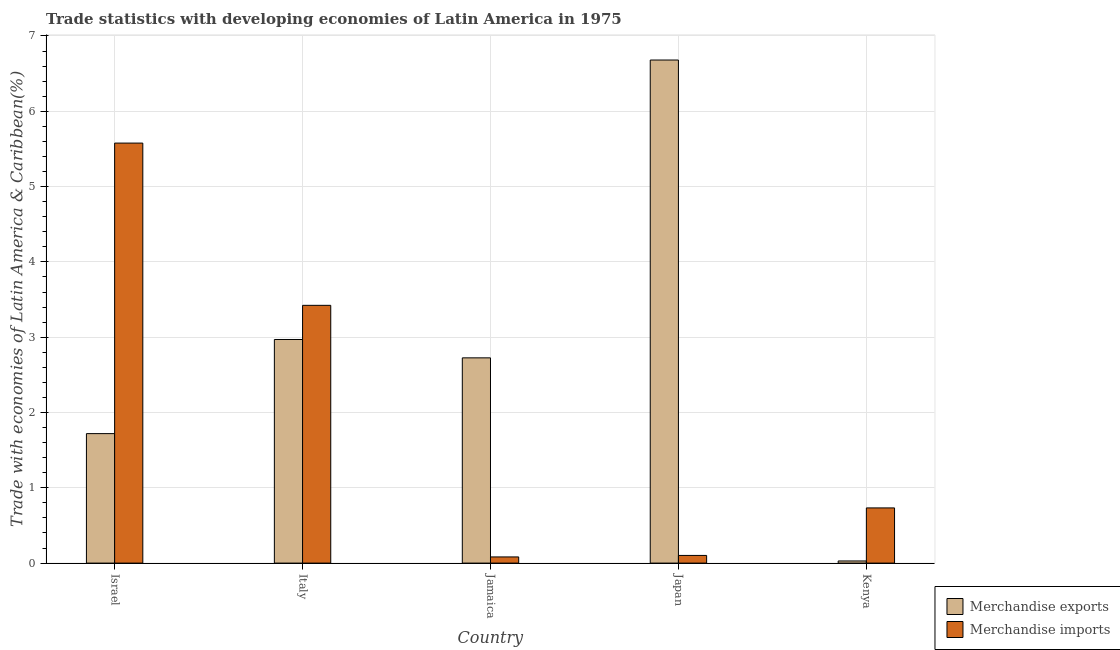Are the number of bars on each tick of the X-axis equal?
Keep it short and to the point. Yes. What is the label of the 1st group of bars from the left?
Your response must be concise. Israel. In how many cases, is the number of bars for a given country not equal to the number of legend labels?
Your answer should be very brief. 0. What is the merchandise exports in Italy?
Make the answer very short. 2.97. Across all countries, what is the maximum merchandise exports?
Make the answer very short. 6.68. Across all countries, what is the minimum merchandise exports?
Your answer should be compact. 0.03. In which country was the merchandise exports minimum?
Keep it short and to the point. Kenya. What is the total merchandise exports in the graph?
Offer a terse response. 14.12. What is the difference between the merchandise exports in Jamaica and that in Japan?
Your answer should be very brief. -3.96. What is the difference between the merchandise exports in Japan and the merchandise imports in Jamaica?
Offer a very short reply. 6.6. What is the average merchandise imports per country?
Make the answer very short. 1.98. What is the difference between the merchandise imports and merchandise exports in Israel?
Your response must be concise. 3.86. In how many countries, is the merchandise exports greater than 4 %?
Make the answer very short. 1. What is the ratio of the merchandise exports in Jamaica to that in Japan?
Your response must be concise. 0.41. Is the merchandise exports in Italy less than that in Jamaica?
Provide a short and direct response. No. What is the difference between the highest and the second highest merchandise imports?
Make the answer very short. 2.15. What is the difference between the highest and the lowest merchandise imports?
Make the answer very short. 5.5. In how many countries, is the merchandise exports greater than the average merchandise exports taken over all countries?
Ensure brevity in your answer.  2. Is the sum of the merchandise exports in Israel and Jamaica greater than the maximum merchandise imports across all countries?
Your response must be concise. No. What does the 1st bar from the left in Kenya represents?
Your answer should be very brief. Merchandise exports. What does the 2nd bar from the right in Israel represents?
Keep it short and to the point. Merchandise exports. How many bars are there?
Ensure brevity in your answer.  10. How many countries are there in the graph?
Give a very brief answer. 5. Are the values on the major ticks of Y-axis written in scientific E-notation?
Provide a succinct answer. No. How many legend labels are there?
Your answer should be compact. 2. How are the legend labels stacked?
Your answer should be very brief. Vertical. What is the title of the graph?
Offer a terse response. Trade statistics with developing economies of Latin America in 1975. Does "Goods and services" appear as one of the legend labels in the graph?
Your answer should be compact. No. What is the label or title of the X-axis?
Your answer should be compact. Country. What is the label or title of the Y-axis?
Give a very brief answer. Trade with economies of Latin America & Caribbean(%). What is the Trade with economies of Latin America & Caribbean(%) in Merchandise exports in Israel?
Your response must be concise. 1.72. What is the Trade with economies of Latin America & Caribbean(%) of Merchandise imports in Israel?
Provide a succinct answer. 5.58. What is the Trade with economies of Latin America & Caribbean(%) in Merchandise exports in Italy?
Give a very brief answer. 2.97. What is the Trade with economies of Latin America & Caribbean(%) in Merchandise imports in Italy?
Your answer should be compact. 3.42. What is the Trade with economies of Latin America & Caribbean(%) of Merchandise exports in Jamaica?
Make the answer very short. 2.73. What is the Trade with economies of Latin America & Caribbean(%) in Merchandise imports in Jamaica?
Ensure brevity in your answer.  0.08. What is the Trade with economies of Latin America & Caribbean(%) of Merchandise exports in Japan?
Offer a terse response. 6.68. What is the Trade with economies of Latin America & Caribbean(%) in Merchandise imports in Japan?
Keep it short and to the point. 0.1. What is the Trade with economies of Latin America & Caribbean(%) in Merchandise exports in Kenya?
Keep it short and to the point. 0.03. What is the Trade with economies of Latin America & Caribbean(%) in Merchandise imports in Kenya?
Offer a very short reply. 0.73. Across all countries, what is the maximum Trade with economies of Latin America & Caribbean(%) in Merchandise exports?
Offer a very short reply. 6.68. Across all countries, what is the maximum Trade with economies of Latin America & Caribbean(%) in Merchandise imports?
Give a very brief answer. 5.58. Across all countries, what is the minimum Trade with economies of Latin America & Caribbean(%) in Merchandise exports?
Provide a succinct answer. 0.03. Across all countries, what is the minimum Trade with economies of Latin America & Caribbean(%) of Merchandise imports?
Your answer should be very brief. 0.08. What is the total Trade with economies of Latin America & Caribbean(%) of Merchandise exports in the graph?
Provide a short and direct response. 14.12. What is the total Trade with economies of Latin America & Caribbean(%) of Merchandise imports in the graph?
Your answer should be compact. 9.92. What is the difference between the Trade with economies of Latin America & Caribbean(%) of Merchandise exports in Israel and that in Italy?
Your answer should be very brief. -1.25. What is the difference between the Trade with economies of Latin America & Caribbean(%) of Merchandise imports in Israel and that in Italy?
Make the answer very short. 2.15. What is the difference between the Trade with economies of Latin America & Caribbean(%) of Merchandise exports in Israel and that in Jamaica?
Offer a terse response. -1.01. What is the difference between the Trade with economies of Latin America & Caribbean(%) of Merchandise imports in Israel and that in Jamaica?
Keep it short and to the point. 5.5. What is the difference between the Trade with economies of Latin America & Caribbean(%) of Merchandise exports in Israel and that in Japan?
Keep it short and to the point. -4.96. What is the difference between the Trade with economies of Latin America & Caribbean(%) of Merchandise imports in Israel and that in Japan?
Your answer should be very brief. 5.48. What is the difference between the Trade with economies of Latin America & Caribbean(%) of Merchandise exports in Israel and that in Kenya?
Your answer should be very brief. 1.69. What is the difference between the Trade with economies of Latin America & Caribbean(%) of Merchandise imports in Israel and that in Kenya?
Give a very brief answer. 4.84. What is the difference between the Trade with economies of Latin America & Caribbean(%) of Merchandise exports in Italy and that in Jamaica?
Give a very brief answer. 0.24. What is the difference between the Trade with economies of Latin America & Caribbean(%) in Merchandise imports in Italy and that in Jamaica?
Your response must be concise. 3.34. What is the difference between the Trade with economies of Latin America & Caribbean(%) in Merchandise exports in Italy and that in Japan?
Make the answer very short. -3.71. What is the difference between the Trade with economies of Latin America & Caribbean(%) of Merchandise imports in Italy and that in Japan?
Provide a short and direct response. 3.32. What is the difference between the Trade with economies of Latin America & Caribbean(%) in Merchandise exports in Italy and that in Kenya?
Your answer should be very brief. 2.94. What is the difference between the Trade with economies of Latin America & Caribbean(%) in Merchandise imports in Italy and that in Kenya?
Your answer should be very brief. 2.69. What is the difference between the Trade with economies of Latin America & Caribbean(%) of Merchandise exports in Jamaica and that in Japan?
Your response must be concise. -3.96. What is the difference between the Trade with economies of Latin America & Caribbean(%) of Merchandise imports in Jamaica and that in Japan?
Provide a succinct answer. -0.02. What is the difference between the Trade with economies of Latin America & Caribbean(%) of Merchandise exports in Jamaica and that in Kenya?
Make the answer very short. 2.7. What is the difference between the Trade with economies of Latin America & Caribbean(%) of Merchandise imports in Jamaica and that in Kenya?
Your answer should be compact. -0.65. What is the difference between the Trade with economies of Latin America & Caribbean(%) in Merchandise exports in Japan and that in Kenya?
Keep it short and to the point. 6.65. What is the difference between the Trade with economies of Latin America & Caribbean(%) in Merchandise imports in Japan and that in Kenya?
Ensure brevity in your answer.  -0.63. What is the difference between the Trade with economies of Latin America & Caribbean(%) of Merchandise exports in Israel and the Trade with economies of Latin America & Caribbean(%) of Merchandise imports in Italy?
Your response must be concise. -1.7. What is the difference between the Trade with economies of Latin America & Caribbean(%) of Merchandise exports in Israel and the Trade with economies of Latin America & Caribbean(%) of Merchandise imports in Jamaica?
Make the answer very short. 1.64. What is the difference between the Trade with economies of Latin America & Caribbean(%) of Merchandise exports in Israel and the Trade with economies of Latin America & Caribbean(%) of Merchandise imports in Japan?
Keep it short and to the point. 1.62. What is the difference between the Trade with economies of Latin America & Caribbean(%) in Merchandise exports in Israel and the Trade with economies of Latin America & Caribbean(%) in Merchandise imports in Kenya?
Provide a succinct answer. 0.99. What is the difference between the Trade with economies of Latin America & Caribbean(%) in Merchandise exports in Italy and the Trade with economies of Latin America & Caribbean(%) in Merchandise imports in Jamaica?
Make the answer very short. 2.89. What is the difference between the Trade with economies of Latin America & Caribbean(%) of Merchandise exports in Italy and the Trade with economies of Latin America & Caribbean(%) of Merchandise imports in Japan?
Your answer should be compact. 2.87. What is the difference between the Trade with economies of Latin America & Caribbean(%) in Merchandise exports in Italy and the Trade with economies of Latin America & Caribbean(%) in Merchandise imports in Kenya?
Give a very brief answer. 2.24. What is the difference between the Trade with economies of Latin America & Caribbean(%) in Merchandise exports in Jamaica and the Trade with economies of Latin America & Caribbean(%) in Merchandise imports in Japan?
Offer a terse response. 2.62. What is the difference between the Trade with economies of Latin America & Caribbean(%) in Merchandise exports in Jamaica and the Trade with economies of Latin America & Caribbean(%) in Merchandise imports in Kenya?
Provide a short and direct response. 1.99. What is the difference between the Trade with economies of Latin America & Caribbean(%) in Merchandise exports in Japan and the Trade with economies of Latin America & Caribbean(%) in Merchandise imports in Kenya?
Keep it short and to the point. 5.95. What is the average Trade with economies of Latin America & Caribbean(%) of Merchandise exports per country?
Give a very brief answer. 2.82. What is the average Trade with economies of Latin America & Caribbean(%) of Merchandise imports per country?
Ensure brevity in your answer.  1.98. What is the difference between the Trade with economies of Latin America & Caribbean(%) of Merchandise exports and Trade with economies of Latin America & Caribbean(%) of Merchandise imports in Israel?
Your response must be concise. -3.86. What is the difference between the Trade with economies of Latin America & Caribbean(%) of Merchandise exports and Trade with economies of Latin America & Caribbean(%) of Merchandise imports in Italy?
Provide a short and direct response. -0.45. What is the difference between the Trade with economies of Latin America & Caribbean(%) in Merchandise exports and Trade with economies of Latin America & Caribbean(%) in Merchandise imports in Jamaica?
Make the answer very short. 2.64. What is the difference between the Trade with economies of Latin America & Caribbean(%) of Merchandise exports and Trade with economies of Latin America & Caribbean(%) of Merchandise imports in Japan?
Give a very brief answer. 6.58. What is the difference between the Trade with economies of Latin America & Caribbean(%) in Merchandise exports and Trade with economies of Latin America & Caribbean(%) in Merchandise imports in Kenya?
Make the answer very short. -0.7. What is the ratio of the Trade with economies of Latin America & Caribbean(%) of Merchandise exports in Israel to that in Italy?
Keep it short and to the point. 0.58. What is the ratio of the Trade with economies of Latin America & Caribbean(%) in Merchandise imports in Israel to that in Italy?
Provide a short and direct response. 1.63. What is the ratio of the Trade with economies of Latin America & Caribbean(%) of Merchandise exports in Israel to that in Jamaica?
Keep it short and to the point. 0.63. What is the ratio of the Trade with economies of Latin America & Caribbean(%) in Merchandise imports in Israel to that in Jamaica?
Provide a succinct answer. 68.1. What is the ratio of the Trade with economies of Latin America & Caribbean(%) in Merchandise exports in Israel to that in Japan?
Offer a very short reply. 0.26. What is the ratio of the Trade with economies of Latin America & Caribbean(%) in Merchandise imports in Israel to that in Japan?
Provide a succinct answer. 54.76. What is the ratio of the Trade with economies of Latin America & Caribbean(%) in Merchandise exports in Israel to that in Kenya?
Make the answer very short. 60.59. What is the ratio of the Trade with economies of Latin America & Caribbean(%) of Merchandise imports in Israel to that in Kenya?
Your response must be concise. 7.61. What is the ratio of the Trade with economies of Latin America & Caribbean(%) in Merchandise exports in Italy to that in Jamaica?
Offer a very short reply. 1.09. What is the ratio of the Trade with economies of Latin America & Caribbean(%) of Merchandise imports in Italy to that in Jamaica?
Your response must be concise. 41.8. What is the ratio of the Trade with economies of Latin America & Caribbean(%) of Merchandise exports in Italy to that in Japan?
Provide a succinct answer. 0.44. What is the ratio of the Trade with economies of Latin America & Caribbean(%) of Merchandise imports in Italy to that in Japan?
Your answer should be compact. 33.61. What is the ratio of the Trade with economies of Latin America & Caribbean(%) in Merchandise exports in Italy to that in Kenya?
Make the answer very short. 104.63. What is the ratio of the Trade with economies of Latin America & Caribbean(%) of Merchandise imports in Italy to that in Kenya?
Your response must be concise. 4.67. What is the ratio of the Trade with economies of Latin America & Caribbean(%) in Merchandise exports in Jamaica to that in Japan?
Your answer should be compact. 0.41. What is the ratio of the Trade with economies of Latin America & Caribbean(%) of Merchandise imports in Jamaica to that in Japan?
Make the answer very short. 0.8. What is the ratio of the Trade with economies of Latin America & Caribbean(%) in Merchandise exports in Jamaica to that in Kenya?
Ensure brevity in your answer.  96.04. What is the ratio of the Trade with economies of Latin America & Caribbean(%) of Merchandise imports in Jamaica to that in Kenya?
Give a very brief answer. 0.11. What is the ratio of the Trade with economies of Latin America & Caribbean(%) in Merchandise exports in Japan to that in Kenya?
Offer a terse response. 235.4. What is the ratio of the Trade with economies of Latin America & Caribbean(%) of Merchandise imports in Japan to that in Kenya?
Provide a succinct answer. 0.14. What is the difference between the highest and the second highest Trade with economies of Latin America & Caribbean(%) in Merchandise exports?
Keep it short and to the point. 3.71. What is the difference between the highest and the second highest Trade with economies of Latin America & Caribbean(%) of Merchandise imports?
Keep it short and to the point. 2.15. What is the difference between the highest and the lowest Trade with economies of Latin America & Caribbean(%) of Merchandise exports?
Provide a succinct answer. 6.65. What is the difference between the highest and the lowest Trade with economies of Latin America & Caribbean(%) in Merchandise imports?
Your answer should be compact. 5.5. 